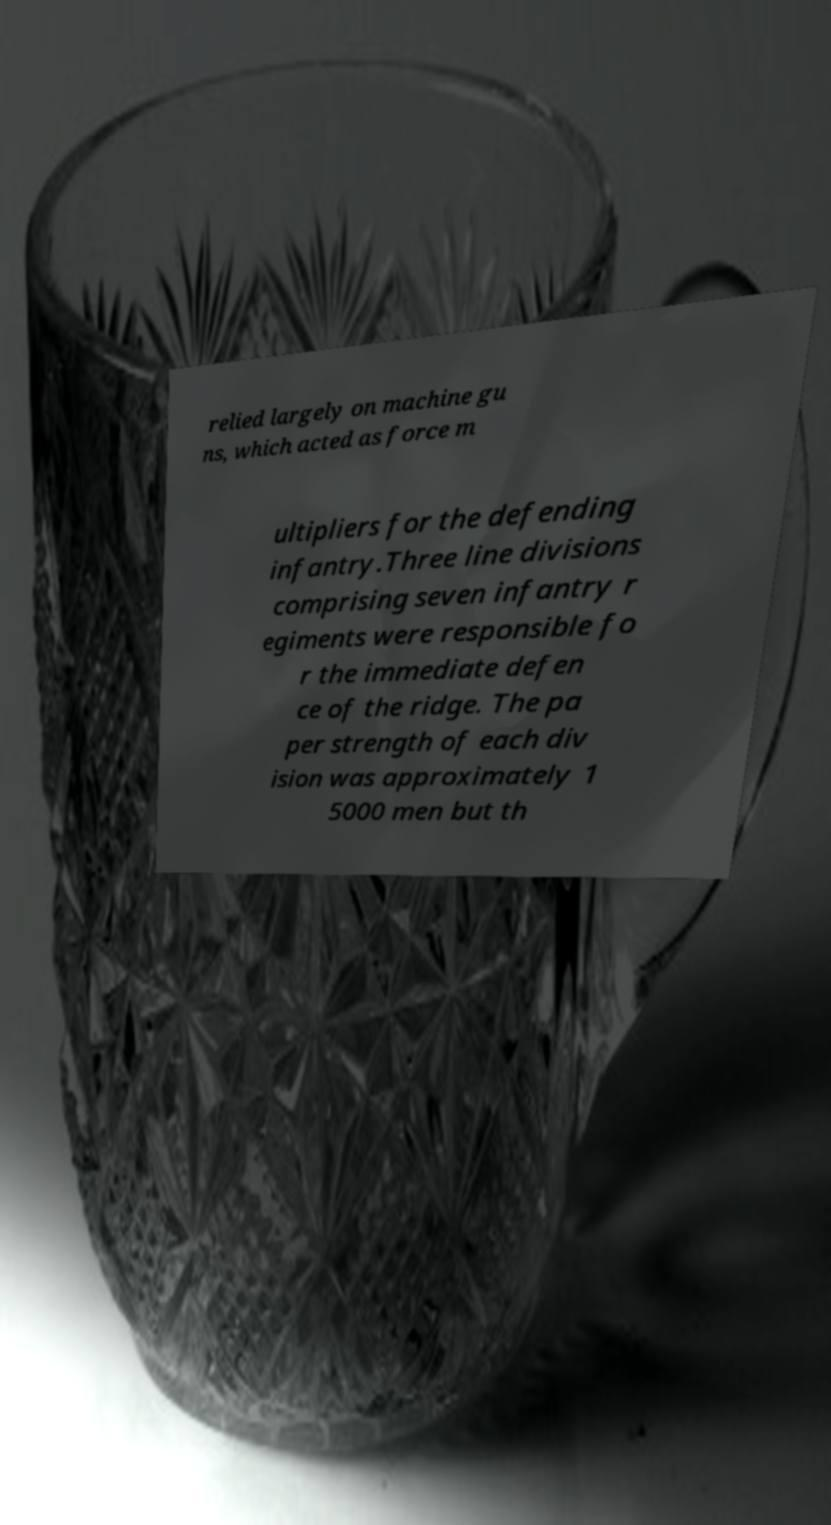Can you read and provide the text displayed in the image?This photo seems to have some interesting text. Can you extract and type it out for me? relied largely on machine gu ns, which acted as force m ultipliers for the defending infantry.Three line divisions comprising seven infantry r egiments were responsible fo r the immediate defen ce of the ridge. The pa per strength of each div ision was approximately 1 5000 men but th 